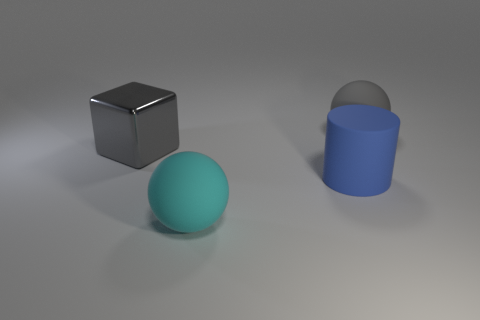Is there anything else that has the same color as the block?
Your answer should be compact. Yes. There is a large thing behind the gray object in front of the rubber sphere behind the metallic cube; what is its material?
Keep it short and to the point. Rubber. The other big object that is the same color as the shiny thing is what shape?
Ensure brevity in your answer.  Sphere. What number of big matte objects are the same color as the block?
Make the answer very short. 1. Do the big thing that is on the right side of the blue matte cylinder and the blue cylinder have the same material?
Keep it short and to the point. Yes. What is the shape of the gray shiny thing?
Provide a short and direct response. Cube. What number of blue objects are tiny shiny cylinders or big balls?
Provide a short and direct response. 0. What number of other things are there of the same material as the large block
Keep it short and to the point. 0. There is a gray thing that is right of the cyan ball; is its shape the same as the cyan matte thing?
Offer a terse response. Yes. Are any gray metal blocks visible?
Your response must be concise. Yes. 